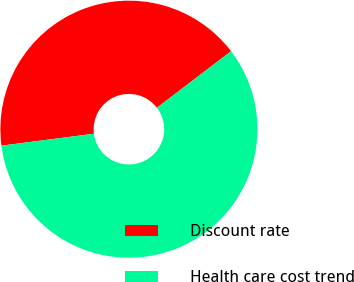Convert chart to OTSL. <chart><loc_0><loc_0><loc_500><loc_500><pie_chart><fcel>Discount rate<fcel>Health care cost trend<nl><fcel>41.67%<fcel>58.33%<nl></chart> 